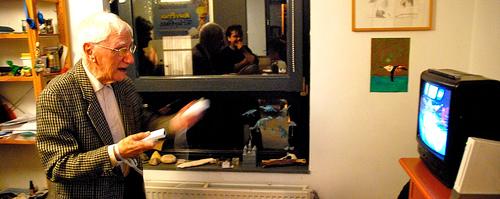What is the man looking at?
Quick response, please. Tv. What is the blue object behind the old man?
Answer briefly. Headphones. What game is the man playing?
Be succinct. Wii. 